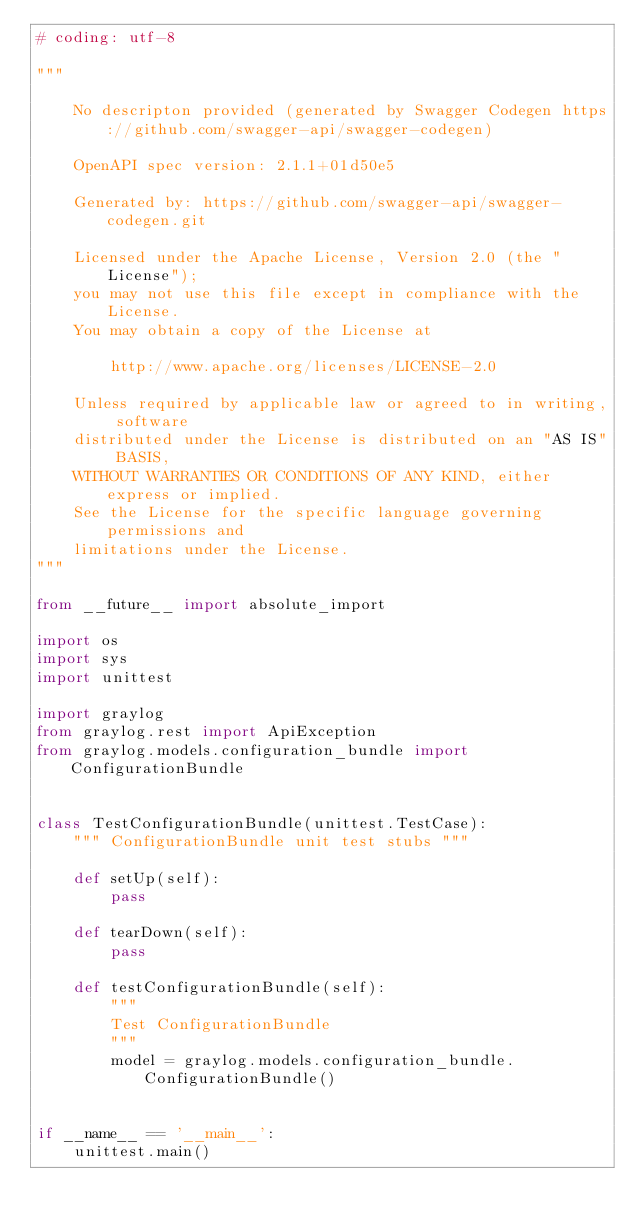<code> <loc_0><loc_0><loc_500><loc_500><_Python_># coding: utf-8

"""

    No descripton provided (generated by Swagger Codegen https://github.com/swagger-api/swagger-codegen)

    OpenAPI spec version: 2.1.1+01d50e5
    
    Generated by: https://github.com/swagger-api/swagger-codegen.git

    Licensed under the Apache License, Version 2.0 (the "License");
    you may not use this file except in compliance with the License.
    You may obtain a copy of the License at

        http://www.apache.org/licenses/LICENSE-2.0

    Unless required by applicable law or agreed to in writing, software
    distributed under the License is distributed on an "AS IS" BASIS,
    WITHOUT WARRANTIES OR CONDITIONS OF ANY KIND, either express or implied.
    See the License for the specific language governing permissions and
    limitations under the License.
"""

from __future__ import absolute_import

import os
import sys
import unittest

import graylog
from graylog.rest import ApiException
from graylog.models.configuration_bundle import ConfigurationBundle


class TestConfigurationBundle(unittest.TestCase):
    """ ConfigurationBundle unit test stubs """

    def setUp(self):
        pass

    def tearDown(self):
        pass

    def testConfigurationBundle(self):
        """
        Test ConfigurationBundle
        """
        model = graylog.models.configuration_bundle.ConfigurationBundle()


if __name__ == '__main__':
    unittest.main()
</code> 